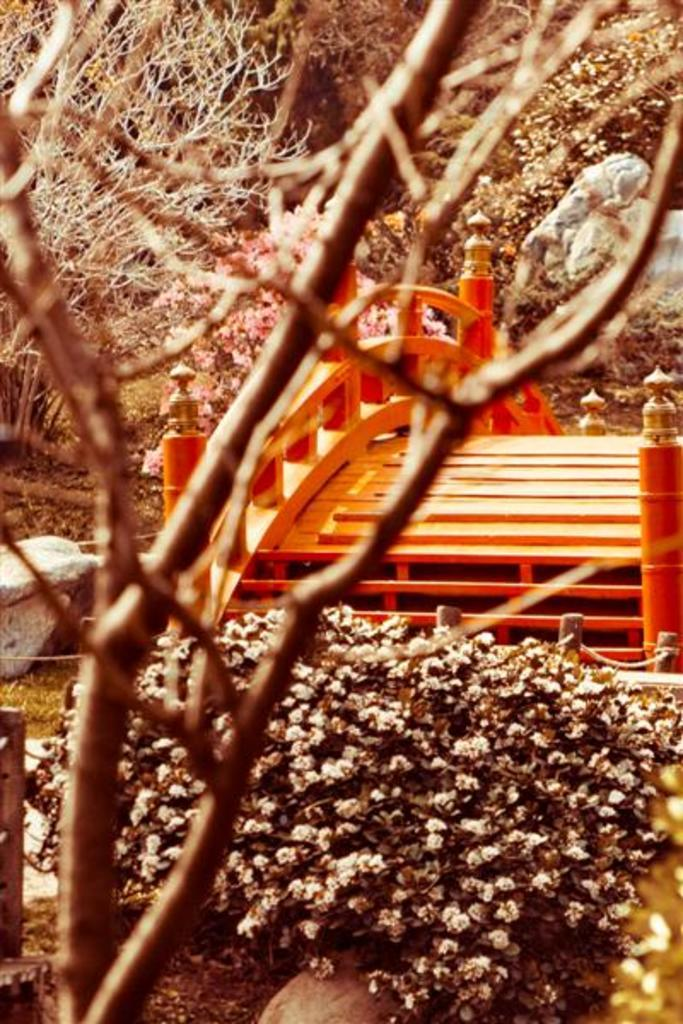What type of plants are at the bottom of the picture? There are plants at the bottom of the picture, but their specific type is not mentioned. What color is the bridge in the image? The bridge in the image is orange-colored. What can be seen in the background of the image? There are many trees in the background of the image. Where might this image have been taken? The image might have been taken in a garden, given the presence of plants and trees. What type of jam is being spread on the bridge in the image? There is no jam present in the image; it features an orange-colored bridge and plants. What kind of noise can be heard coming from the trees in the background? The image is a still picture, so no noise or sound can be heard from the trees or any other elements in the image. 